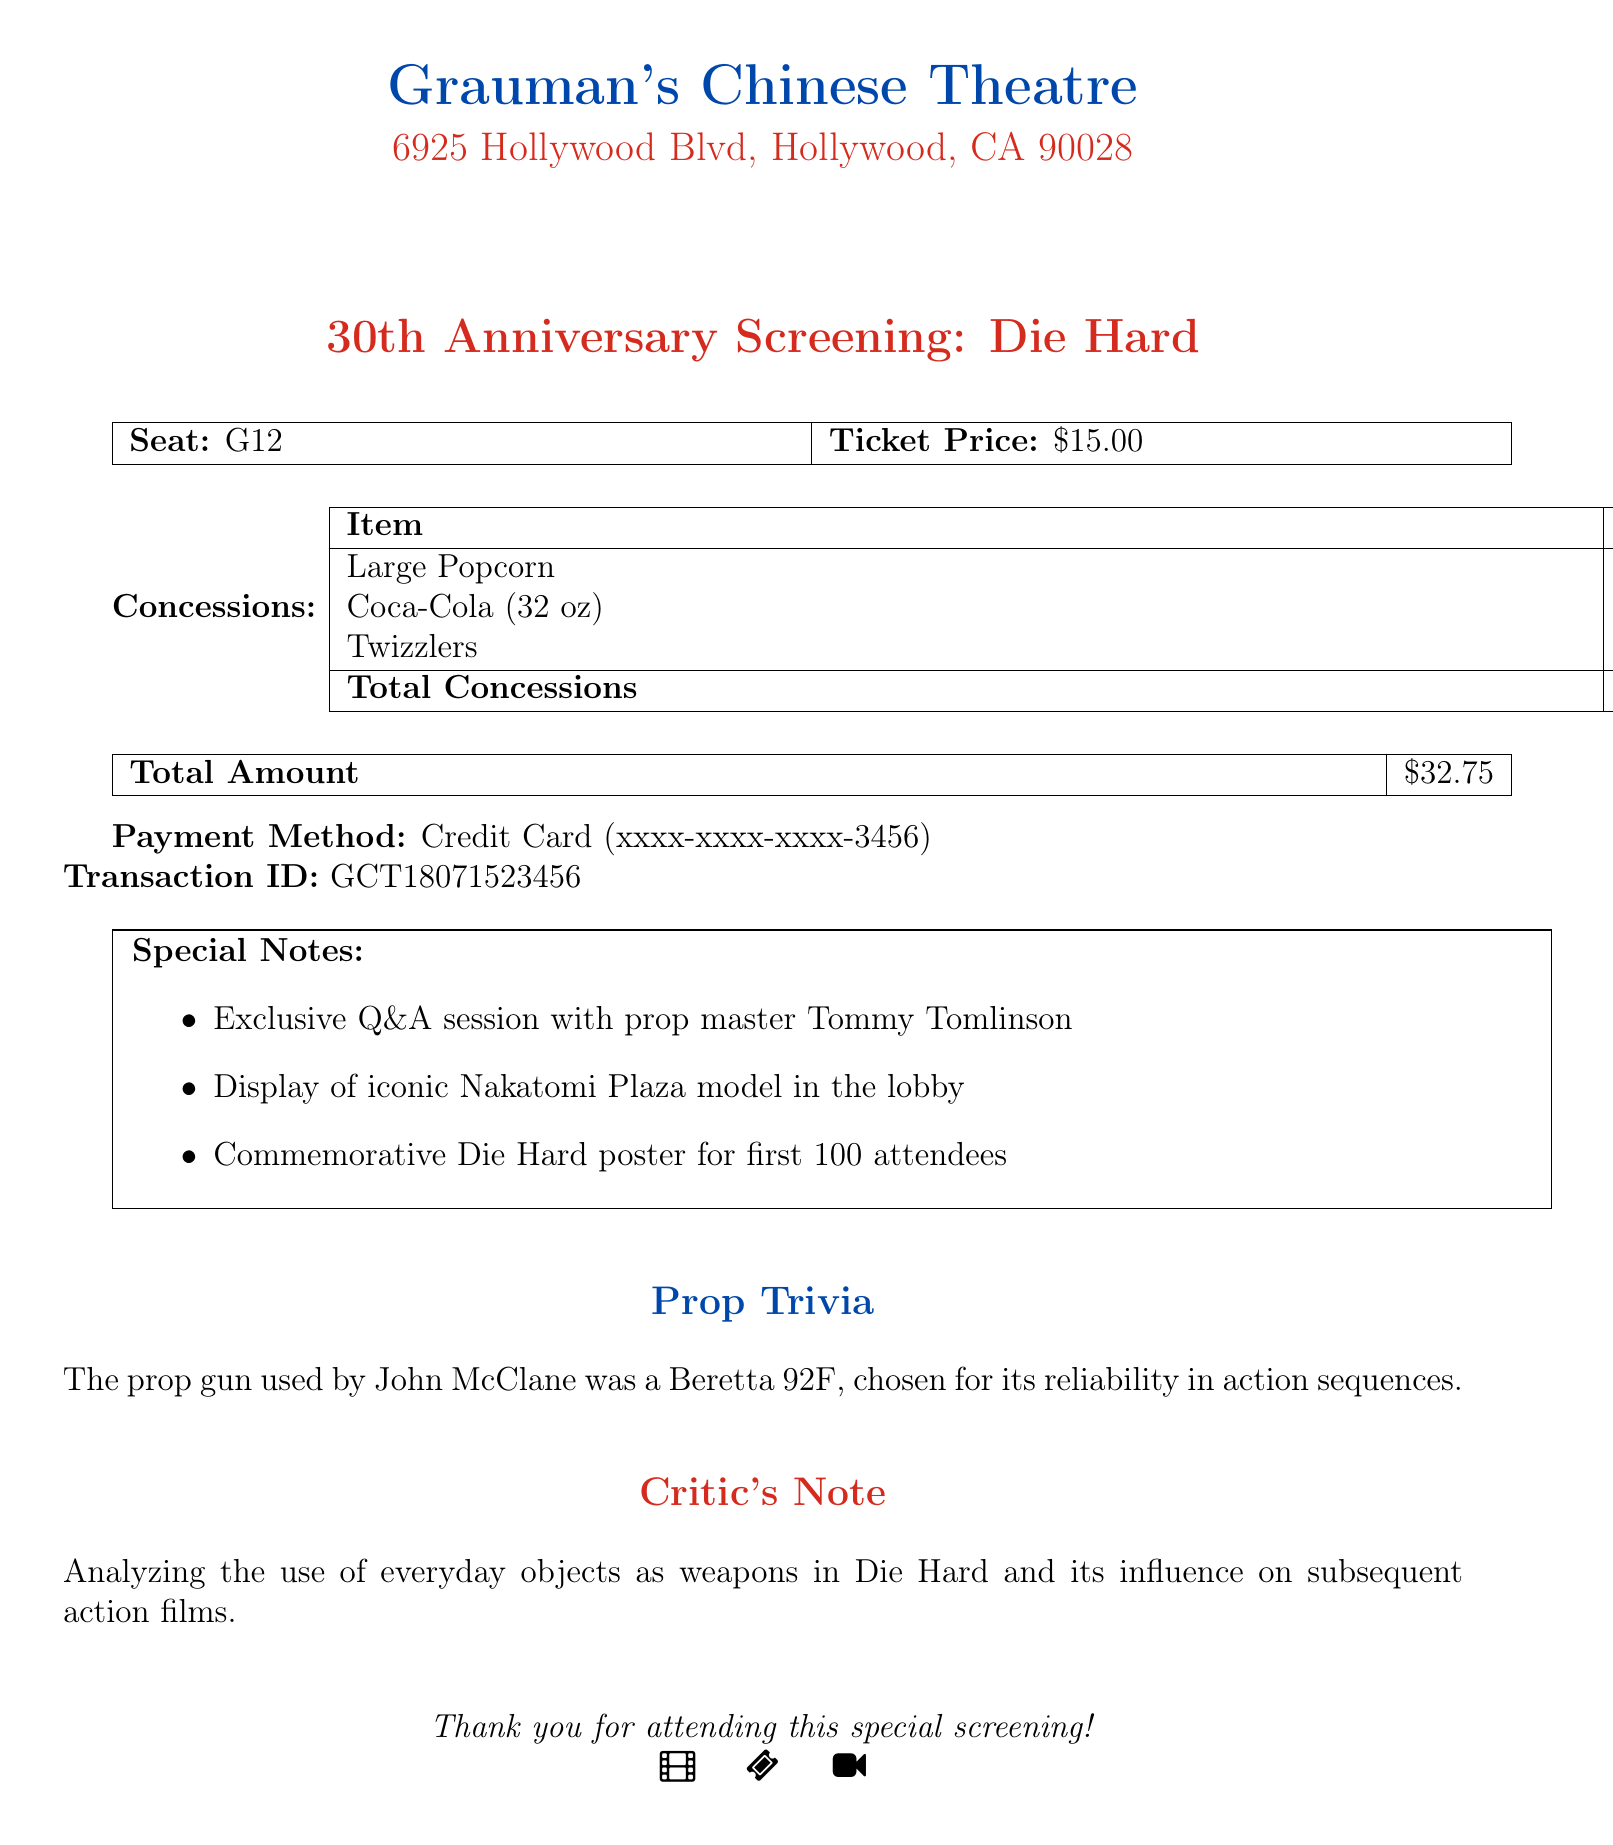What is the name of the theater? The theater name is explicitly stated in the document as "Grauman's Chinese Theatre."
Answer: Grauman's Chinese Theatre What is the seat number? The document lists the seat number as "G12."
Answer: G12 When was the screening event held? The date of the event is clearly mentioned in the document as "July 15, 2018."
Answer: July 15, 2018 What is the ticket price? The document specifies the ticket price as "$15.00."
Answer: $15.00 What type of drink was purchased? The concessions list includes "Coca-Cola (32 oz)" as one of the items.
Answer: Coca-Cola (32 oz) How much was spent on concessions in total? The total concessions amount is provided in the document as "$17.75."
Answer: $17.75 Who was the special guest at the screening? The document notes that "prop master Tommy Tomlinson" attended the special Q&A session.
Answer: Tommy Tomlinson What iconic model was displayed in the lobby? The special notes indicate that an "iconic Nakatomi Plaza model" was displayed in the lobby.
Answer: Nakatomi Plaza model What is the significance of the prop trivia mentioned? The trivia discusses the reliability of the Beretta 92F prop gun used by John McClane in action sequences.
Answer: Beretta 92F Why is the critic's note relevant? The critic's note explains the analysis of everyday objects as weapons influence in action films.
Answer: Everyday objects as weapons 